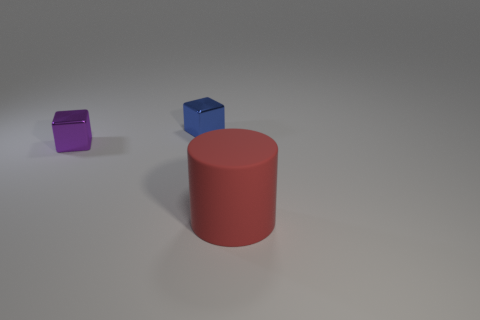Subtract all blue cubes. How many cubes are left? 1 Subtract all cylinders. How many objects are left? 2 Subtract 1 blocks. How many blocks are left? 1 Add 2 small purple cubes. How many objects exist? 5 Add 2 blue rubber things. How many blue rubber things exist? 2 Subtract 1 red cylinders. How many objects are left? 2 Subtract all purple cubes. Subtract all cyan balls. How many cubes are left? 1 Subtract all tiny gray cylinders. Subtract all small objects. How many objects are left? 1 Add 3 big cylinders. How many big cylinders are left? 4 